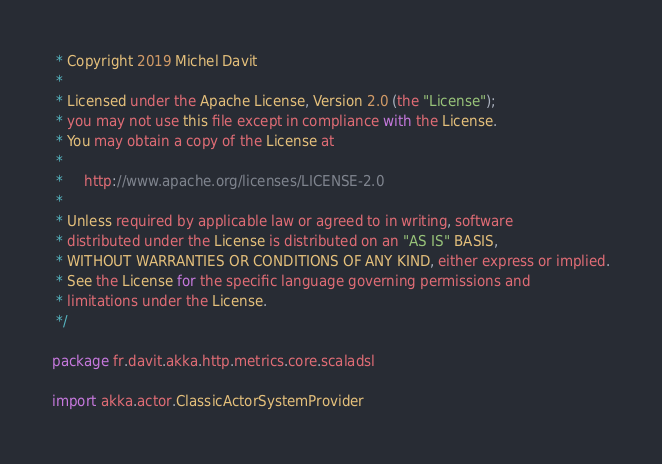<code> <loc_0><loc_0><loc_500><loc_500><_Scala_> * Copyright 2019 Michel Davit
 *
 * Licensed under the Apache License, Version 2.0 (the "License");
 * you may not use this file except in compliance with the License.
 * You may obtain a copy of the License at
 *
 *     http://www.apache.org/licenses/LICENSE-2.0
 *
 * Unless required by applicable law or agreed to in writing, software
 * distributed under the License is distributed on an "AS IS" BASIS,
 * WITHOUT WARRANTIES OR CONDITIONS OF ANY KIND, either express or implied.
 * See the License for the specific language governing permissions and
 * limitations under the License.
 */

package fr.davit.akka.http.metrics.core.scaladsl

import akka.actor.ClassicActorSystemProvider</code> 